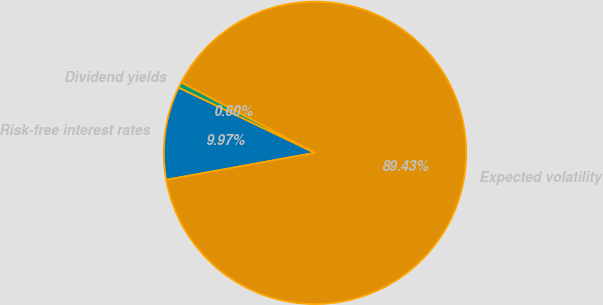<chart> <loc_0><loc_0><loc_500><loc_500><pie_chart><fcel>Risk-free interest rates<fcel>Expected volatility<fcel>Dividend yields<nl><fcel>9.97%<fcel>89.43%<fcel>0.6%<nl></chart> 